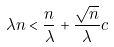<formula> <loc_0><loc_0><loc_500><loc_500>\lambda n < \frac { n } { \lambda } + \frac { \sqrt { n } } { \lambda } c</formula> 